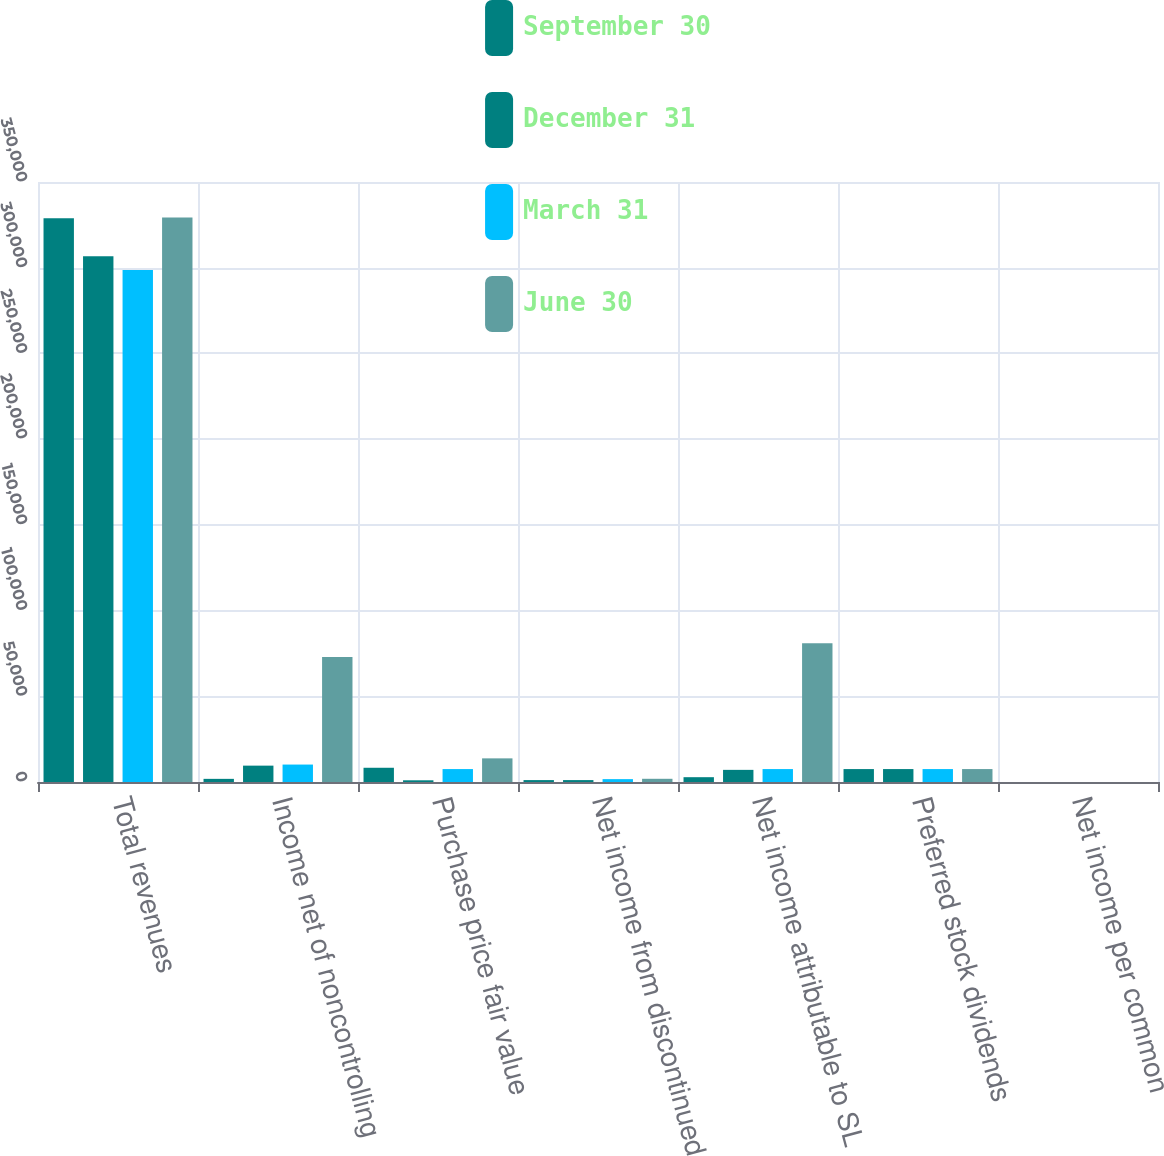Convert chart to OTSL. <chart><loc_0><loc_0><loc_500><loc_500><stacked_bar_chart><ecel><fcel>Total revenues<fcel>Income net of noncontrolling<fcel>Purchase price fair value<fcel>Net income from discontinued<fcel>Net income attributable to SL<fcel>Preferred stock dividends<fcel>Net income per common<nl><fcel>September 30<fcel>328877<fcel>1833<fcel>8306<fcel>1116<fcel>2808<fcel>7543<fcel>0.03<nl><fcel>December 31<fcel>306624<fcel>9544<fcel>999<fcel>1116<fcel>7079<fcel>7545<fcel>0.08<nl><fcel>March 31<fcel>298705<fcel>10176<fcel>7545<fcel>1675<fcel>7545<fcel>7545<fcel>6.3<nl><fcel>June 30<fcel>329222<fcel>72898<fcel>13788<fcel>1873<fcel>80887<fcel>7545<fcel>1.02<nl></chart> 